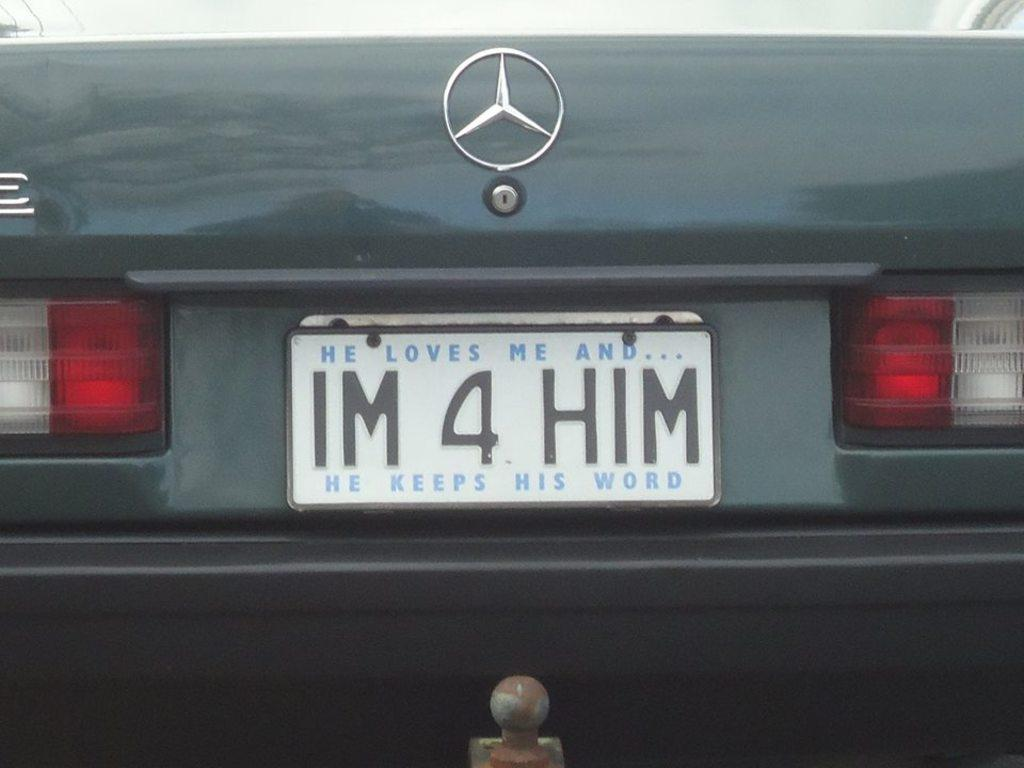<image>
Write a terse but informative summary of the picture. an im 4 him license plate on a car 